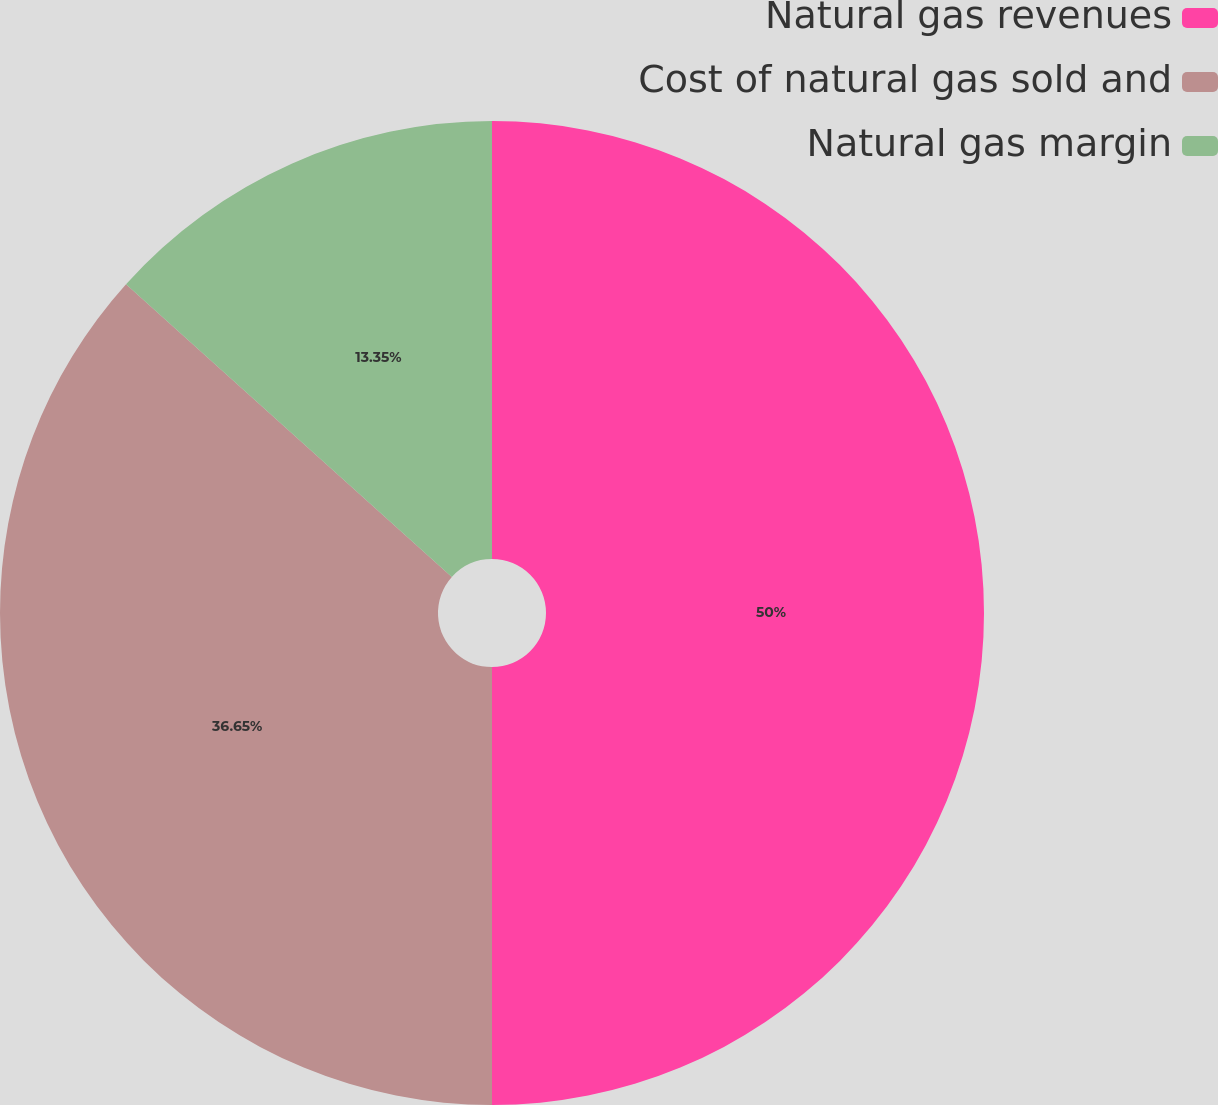<chart> <loc_0><loc_0><loc_500><loc_500><pie_chart><fcel>Natural gas revenues<fcel>Cost of natural gas sold and<fcel>Natural gas margin<nl><fcel>50.0%<fcel>36.65%<fcel>13.35%<nl></chart> 